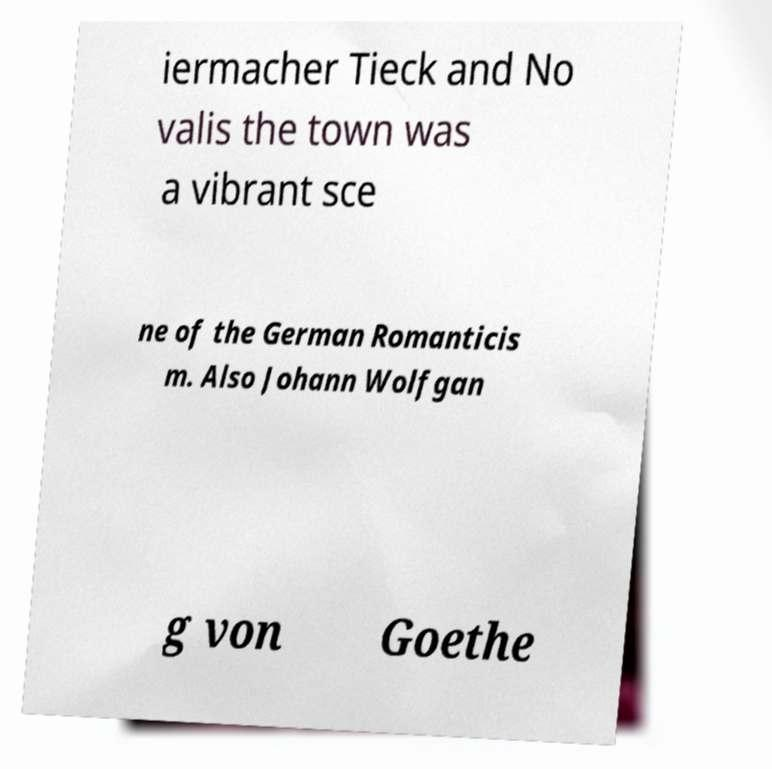For documentation purposes, I need the text within this image transcribed. Could you provide that? iermacher Tieck and No valis the town was a vibrant sce ne of the German Romanticis m. Also Johann Wolfgan g von Goethe 